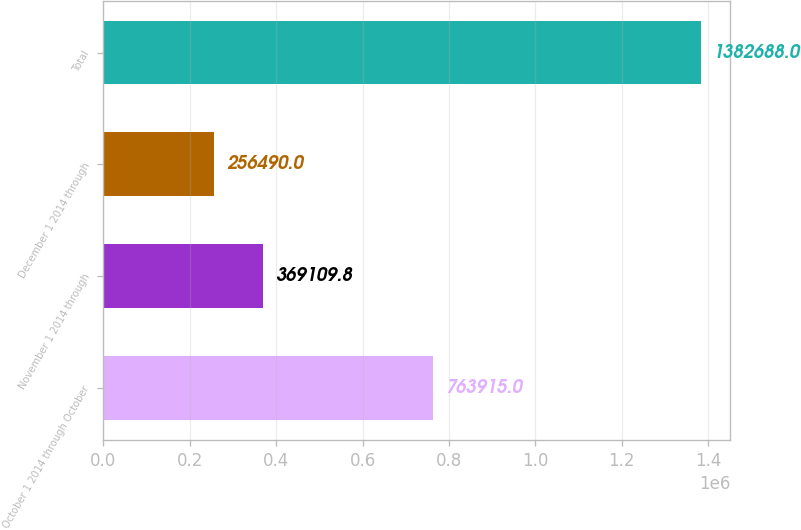<chart> <loc_0><loc_0><loc_500><loc_500><bar_chart><fcel>October 1 2014 through October<fcel>November 1 2014 through<fcel>December 1 2014 through<fcel>Total<nl><fcel>763915<fcel>369110<fcel>256490<fcel>1.38269e+06<nl></chart> 